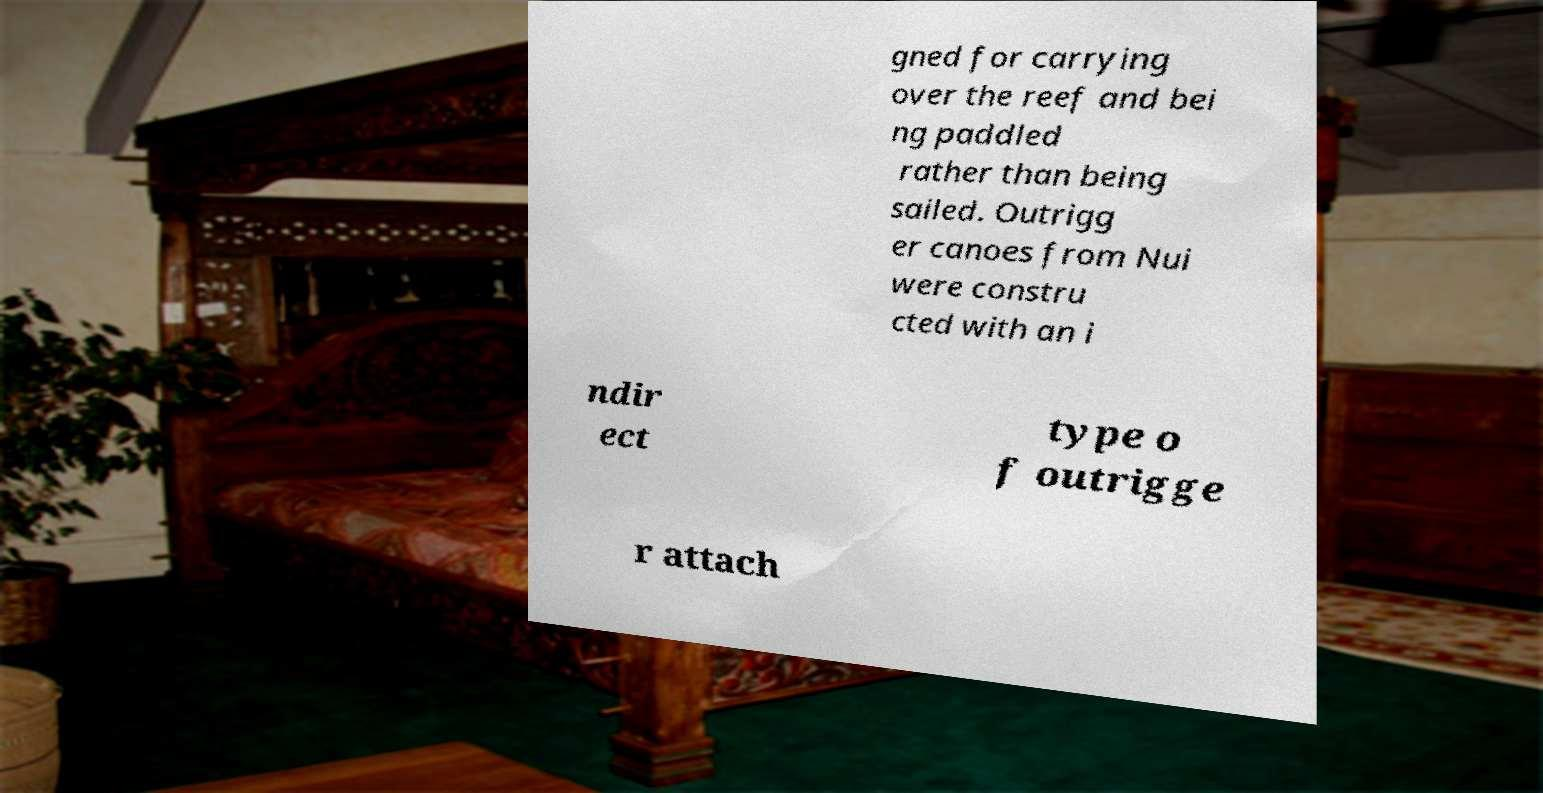What messages or text are displayed in this image? I need them in a readable, typed format. gned for carrying over the reef and bei ng paddled rather than being sailed. Outrigg er canoes from Nui were constru cted with an i ndir ect type o f outrigge r attach 